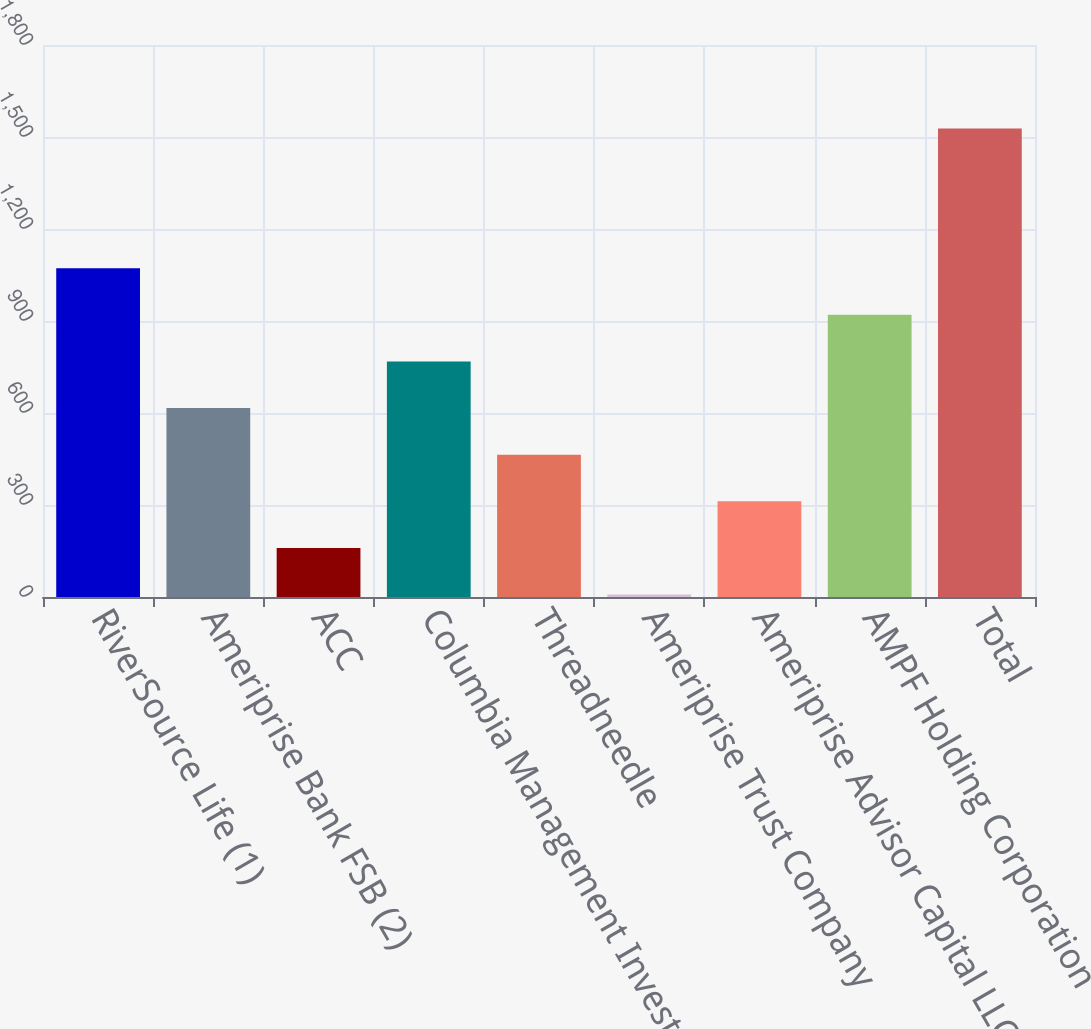Convert chart. <chart><loc_0><loc_0><loc_500><loc_500><bar_chart><fcel>RiverSource Life (1)<fcel>Ameriprise Bank FSB (2)<fcel>ACC<fcel>Columbia Management Investment<fcel>Threadneedle<fcel>Ameriprise Trust Company<fcel>Ameriprise Advisor Capital LLC<fcel>AMPF Holding Corporation<fcel>Total<nl><fcel>1072<fcel>616<fcel>160<fcel>768<fcel>464<fcel>8<fcel>312<fcel>920<fcel>1528<nl></chart> 